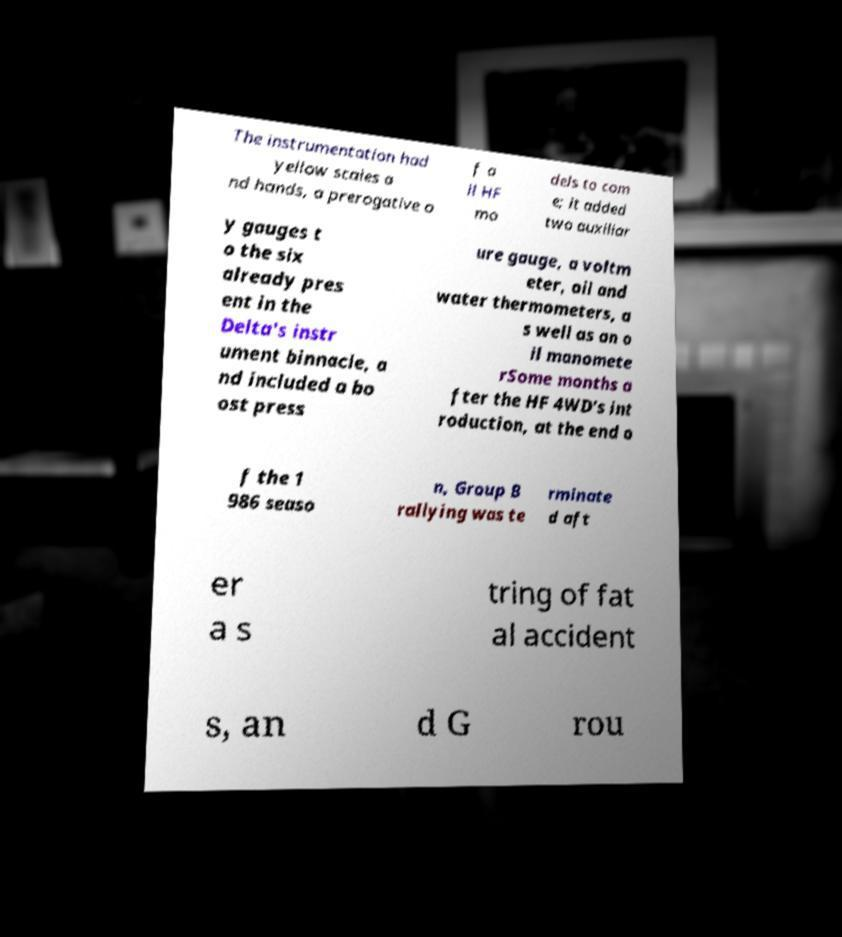For documentation purposes, I need the text within this image transcribed. Could you provide that? The instrumentation had yellow scales a nd hands, a prerogative o f a ll HF mo dels to com e; it added two auxiliar y gauges t o the six already pres ent in the Delta's instr ument binnacle, a nd included a bo ost press ure gauge, a voltm eter, oil and water thermometers, a s well as an o il manomete rSome months a fter the HF 4WD's int roduction, at the end o f the 1 986 seaso n, Group B rallying was te rminate d aft er a s tring of fat al accident s, an d G rou 